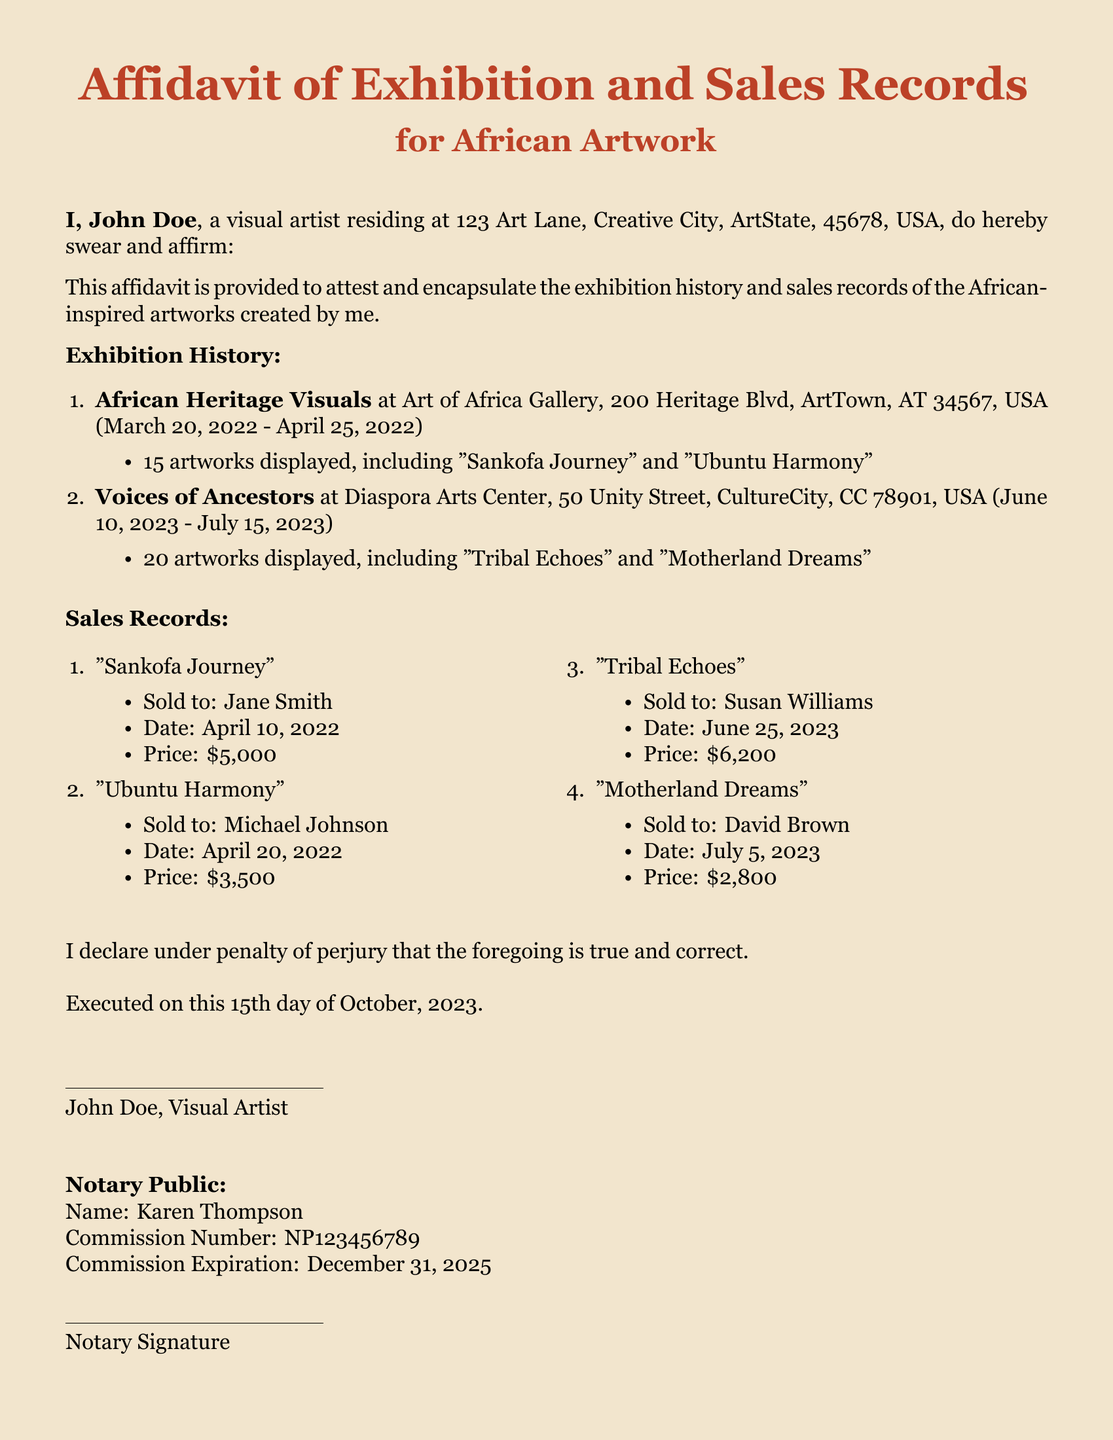what is the name of the visual artist? The name of the visual artist as stated in the affidavit is John Doe.
Answer: John Doe how many artworks were displayed in the "Voices of Ancestors" exhibition? The document states that 20 artworks were displayed in this exhibition.
Answer: 20 who purchased "Sankofa Journey"? The affidavit records that "Sankofa Journey" was sold to Jane Smith.
Answer: Jane Smith what is the price of "Tribal Echoes"? According to the sales records, "Tribal Echoes" was sold for $6,200.
Answer: $6,200 when was the affidavit executed? The document specifies that the affidavit was executed on October 15, 2023.
Answer: October 15, 2023 what is the commission expiration date for the notary public? The affidavit states that the commission expiration date for the notary public is December 31, 2025.
Answer: December 31, 2025 how many exhibitions are listed in the affidavit? The affidavit lists two exhibitions in the exhibition history.
Answer: 2 what is the address of the Diaspora Arts Center? The document provides the address as 50 Unity Street, CultureCity, CC 78901, USA.
Answer: 50 Unity Street, CultureCity, CC 78901, USA who is the notary public for this affidavit? The name of the notary public listed in the affidavit is Karen Thompson.
Answer: Karen Thompson 